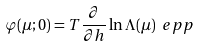Convert formula to latex. <formula><loc_0><loc_0><loc_500><loc_500>\varphi ( \mu ; 0 ) = T \frac { \partial } { \partial h } \ln \Lambda ( \mu ) \ e p p</formula> 